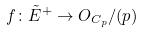<formula> <loc_0><loc_0><loc_500><loc_500>f \colon \tilde { E } ^ { + } \rightarrow O _ { C _ { p } } / ( p )</formula> 